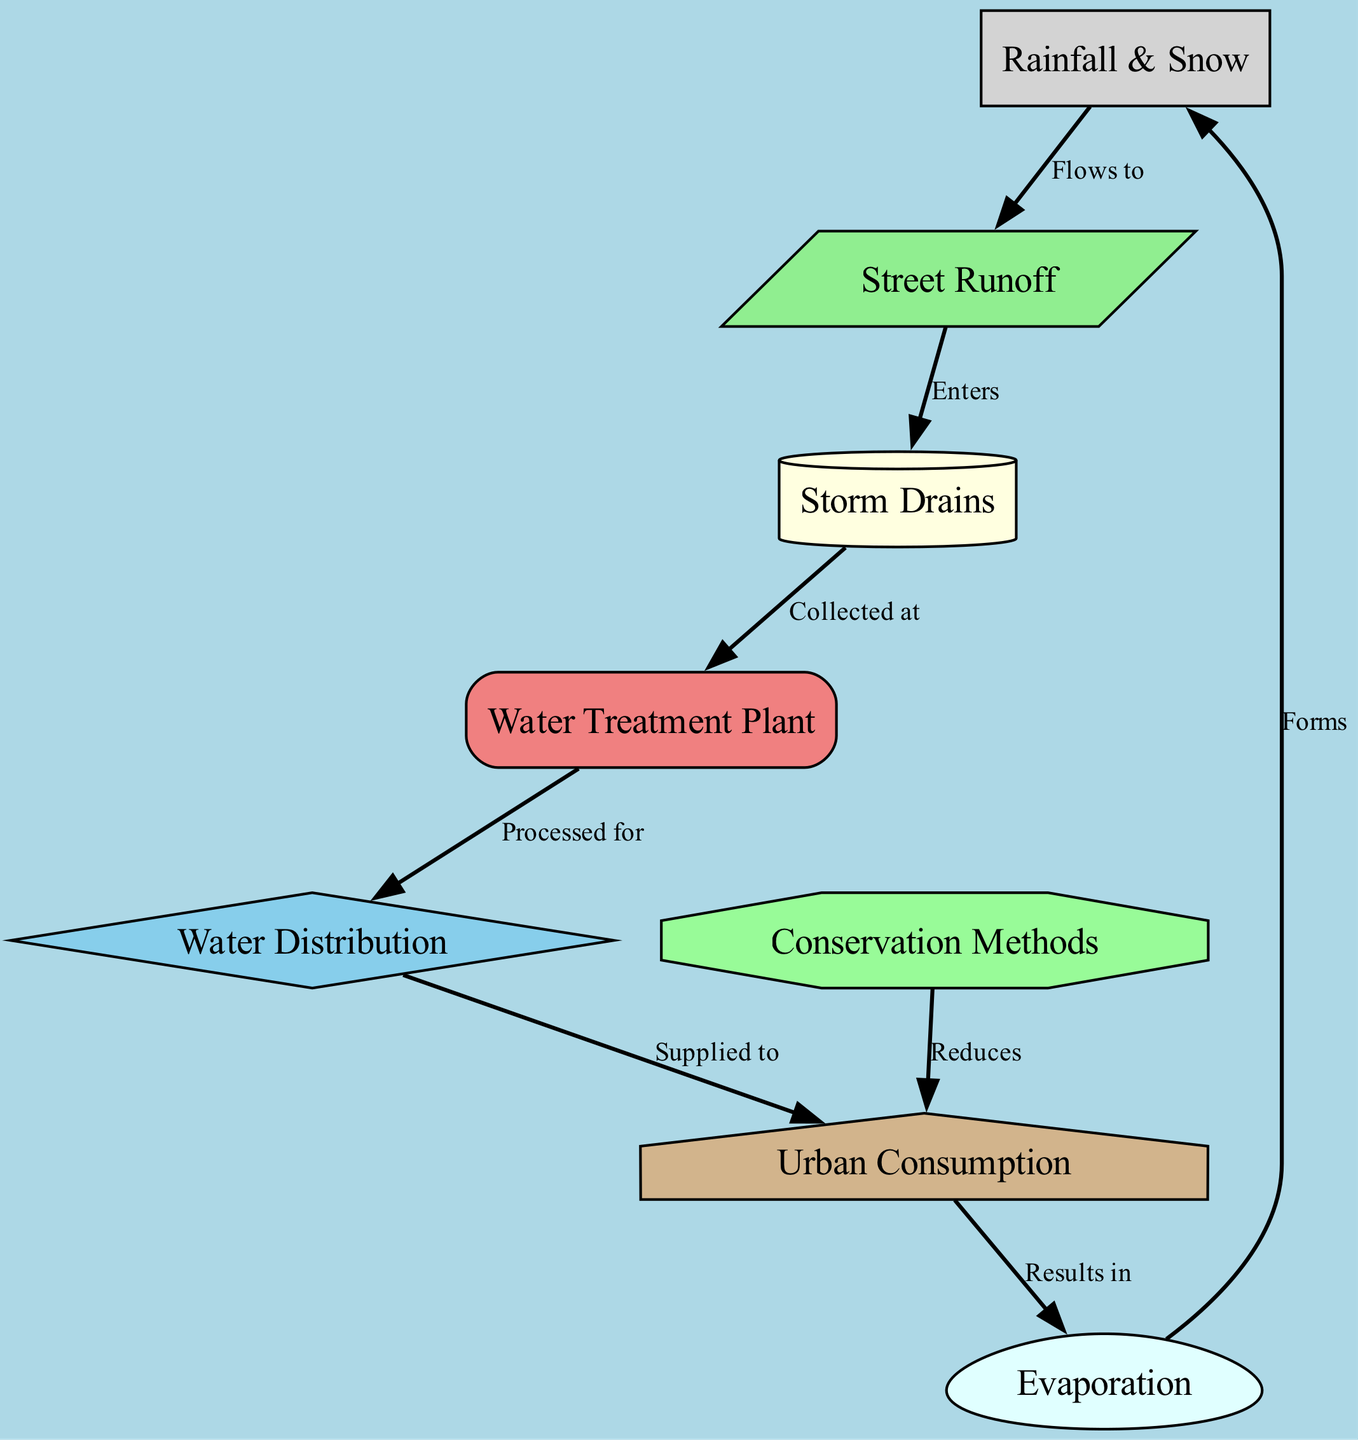What is the starting point of the water cycle in this diagram? The starting point of the water cycle is represented by the "Rainfall & Snow" node, which indicates the phenomenon of precipitation. This node is the first in the flow of the cycle, leading to runoff.
Answer: Rainfall & Snow How many nodes are present in the diagram? The diagram contains a total of eight nodes, each representing different stages or concepts in the urban water cycle. They include precipitation, runoff, storm drains, treatment plant, distribution, consumption, evaporation, and conservation methods.
Answer: 8 Which node results in evaporation? The "Urban Consumption" node leads to the "Evaporation" node, indicating that the usage of water by the urban population results in evaporation. This step signifies water returning to the atmosphere after being used.
Answer: Urban Consumption What does "Storm Drains" collect? The "Storm Drains" node collects water from the "Street Runoff." This indicates that runoff water from streets is channeled into storm drains for further processing.
Answer: Water from Street Runoff What effect do conservation methods have on consumption? The "Conservation Methods" node reduces the "Urban Consumption," suggesting that implementing these methods leads to lower water use in the urban environment, thereby promoting efficiency and sustainability.
Answer: Reduces How does evaporation relate to precipitation in the cycle? The "Evaporation" node forms "Rainfall & Snow," indicating a cyclical relationship where water vaporizing into the atmosphere eventually leads to precipitation, completing the water cycle.
Answer: Forms What is the last node in the water flow process? The last node in the flow is "Urban Consumption," which signifies the final use of water before it returns to the cycle through evaporation. This node represents the endpoint of how water is consumed in the urban setting.
Answer: Urban Consumption Which node processes water for distribution? The "Water Treatment Plant" node processes water obtained from storm drains to ensure it is safe and suitable for distribution to consumers. This step is critical for maintaining water quality in urban environments.
Answer: Water Treatment Plant 